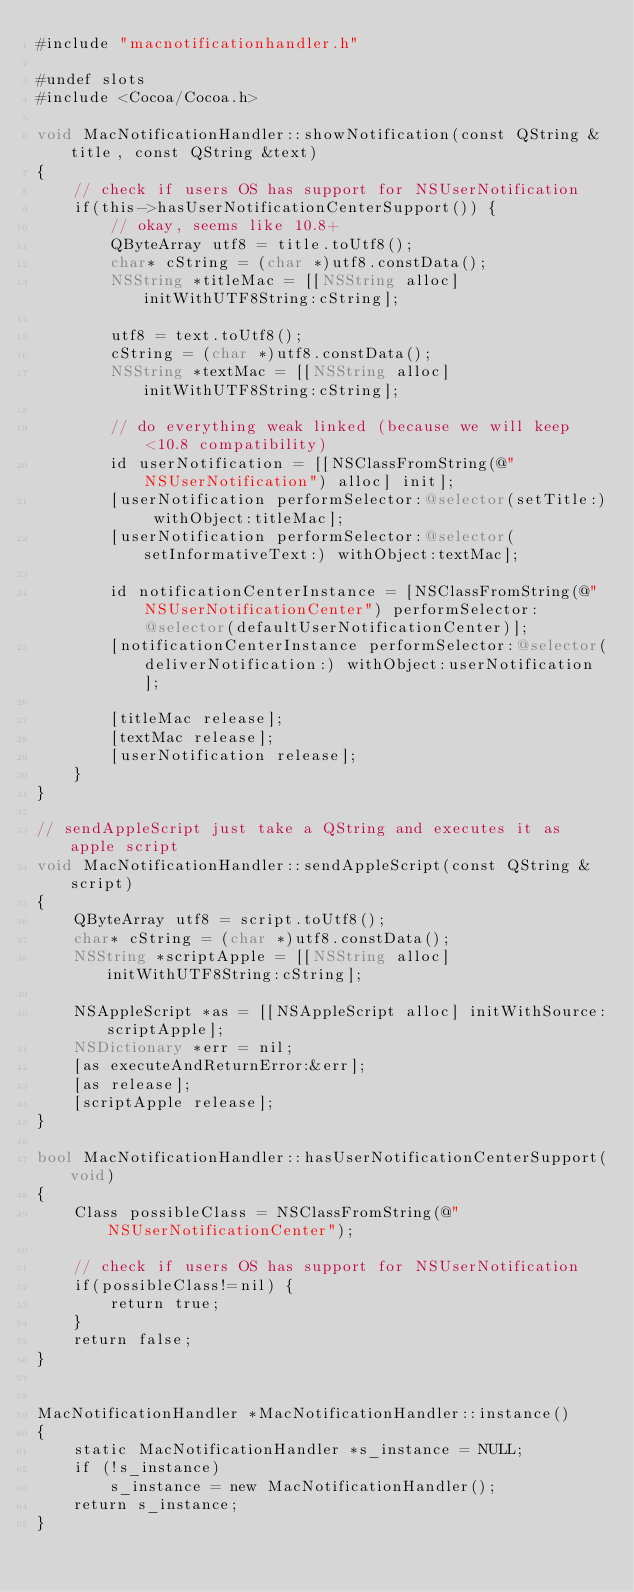Convert code to text. <code><loc_0><loc_0><loc_500><loc_500><_ObjectiveC_>#include "macnotificationhandler.h"

#undef slots
#include <Cocoa/Cocoa.h>

void MacNotificationHandler::showNotification(const QString &title, const QString &text)
{
    // check if users OS has support for NSUserNotification
    if(this->hasUserNotificationCenterSupport()) {
        // okay, seems like 10.8+
        QByteArray utf8 = title.toUtf8();
        char* cString = (char *)utf8.constData();
        NSString *titleMac = [[NSString alloc] initWithUTF8String:cString];

        utf8 = text.toUtf8();
        cString = (char *)utf8.constData();
        NSString *textMac = [[NSString alloc] initWithUTF8String:cString];

        // do everything weak linked (because we will keep <10.8 compatibility)
        id userNotification = [[NSClassFromString(@"NSUserNotification") alloc] init];
        [userNotification performSelector:@selector(setTitle:) withObject:titleMac];
        [userNotification performSelector:@selector(setInformativeText:) withObject:textMac];

        id notificationCenterInstance = [NSClassFromString(@"NSUserNotificationCenter") performSelector:@selector(defaultUserNotificationCenter)];
        [notificationCenterInstance performSelector:@selector(deliverNotification:) withObject:userNotification];

        [titleMac release];
        [textMac release];
        [userNotification release];
    }
}

// sendAppleScript just take a QString and executes it as apple script
void MacNotificationHandler::sendAppleScript(const QString &script)
{
    QByteArray utf8 = script.toUtf8();
    char* cString = (char *)utf8.constData();
    NSString *scriptApple = [[NSString alloc] initWithUTF8String:cString];

    NSAppleScript *as = [[NSAppleScript alloc] initWithSource:scriptApple];
    NSDictionary *err = nil;
    [as executeAndReturnError:&err];
    [as release];
    [scriptApple release];
}

bool MacNotificationHandler::hasUserNotificationCenterSupport(void)
{
    Class possibleClass = NSClassFromString(@"NSUserNotificationCenter");

    // check if users OS has support for NSUserNotification
    if(possibleClass!=nil) {
        return true;
    }
    return false;
}


MacNotificationHandler *MacNotificationHandler::instance()
{
    static MacNotificationHandler *s_instance = NULL;
    if (!s_instance)
        s_instance = new MacNotificationHandler();
    return s_instance;
}

</code> 